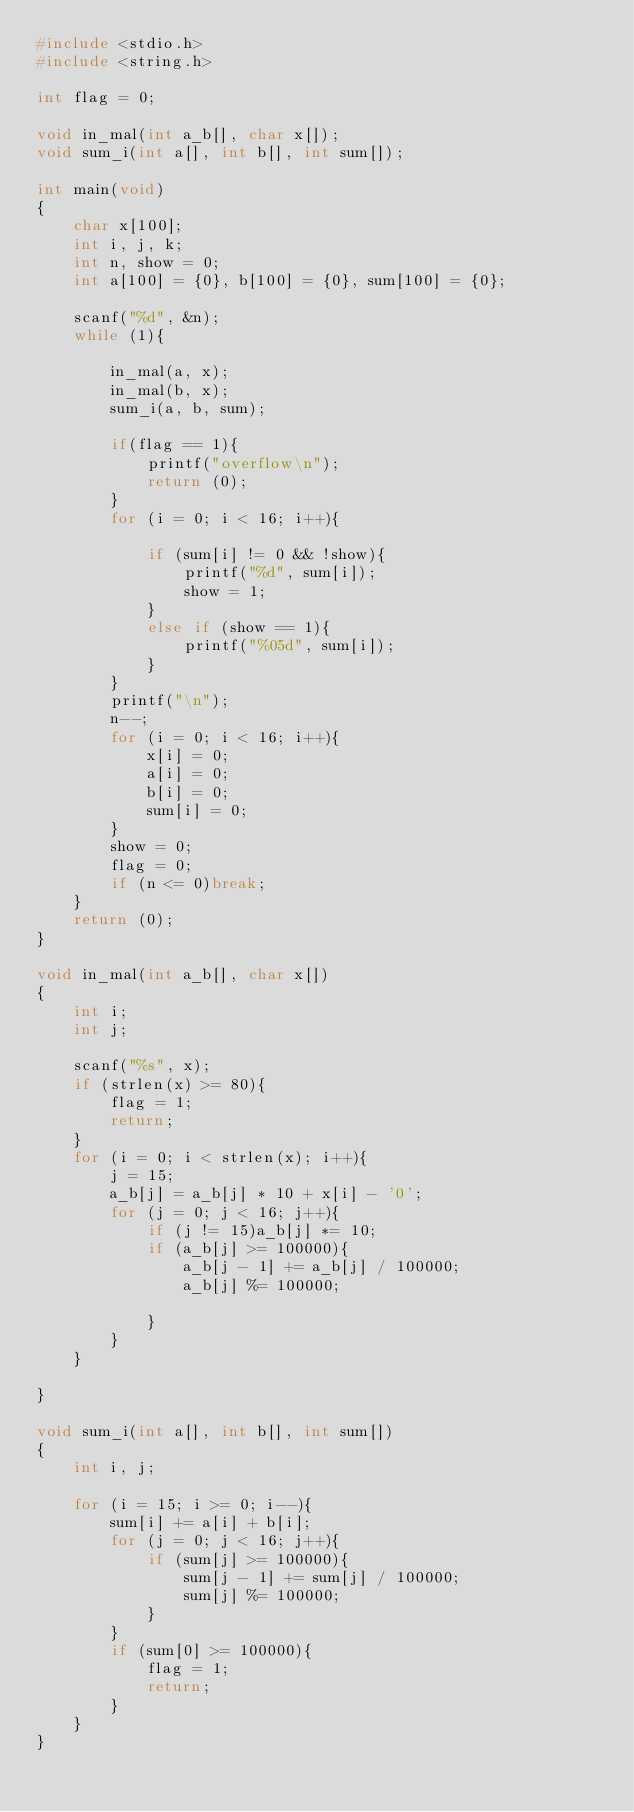Convert code to text. <code><loc_0><loc_0><loc_500><loc_500><_C_>#include <stdio.h>
#include <string.h>

int flag = 0;

void in_mal(int a_b[], char x[]);
void sum_i(int a[], int b[], int sum[]);

int main(void)
{
	char x[100];
	int i, j, k;
	int n, show = 0;
	int a[100] = {0}, b[100] = {0}, sum[100] = {0};
	
	scanf("%d", &n); 
	while (1){
		
		in_mal(a, x);
		in_mal(b, x);
		sum_i(a, b, sum);
		
		if(flag == 1){
			printf("overflow\n");
			return (0);
		}
		for (i = 0; i < 16; i++){
			
			if (sum[i] != 0 && !show){
				printf("%d", sum[i]);
				show = 1;
			}
			else if (show == 1){
				printf("%05d", sum[i]);
			}
		}
		printf("\n");
		n--;
		for (i = 0; i < 16; i++){
			x[i] = 0;
			a[i] = 0;
			b[i] = 0;
			sum[i] = 0;
		}
		show = 0;
		flag = 0;
		if (n <= 0)break;
	}
	return (0);
}

void in_mal(int a_b[], char x[])
{
	int i;
	int j;
	
	scanf("%s", x);
	if (strlen(x) >= 80){
		flag = 1;
		return;
	}
	for (i = 0; i < strlen(x); i++){
		j = 15;
		a_b[j] = a_b[j] * 10 + x[i] - '0';
		for (j = 0; j < 16; j++){
			if (j != 15)a_b[j] *= 10;
			if (a_b[j] >= 100000){
				a_b[j - 1] += a_b[j] / 100000;
				a_b[j] %= 100000;
				
			}
		}
	}

}

void sum_i(int a[], int b[], int sum[])
{
	int i, j;
	
	for (i = 15; i >= 0; i--){
		sum[i] += a[i] + b[i];
		for (j = 0; j < 16; j++){
			if (sum[j] >= 100000){
				sum[j - 1] += sum[j] / 100000;
				sum[j] %= 100000;
			}
		}
		if (sum[0] >= 100000){
			flag = 1;
			return;
		}
	}
}</code> 